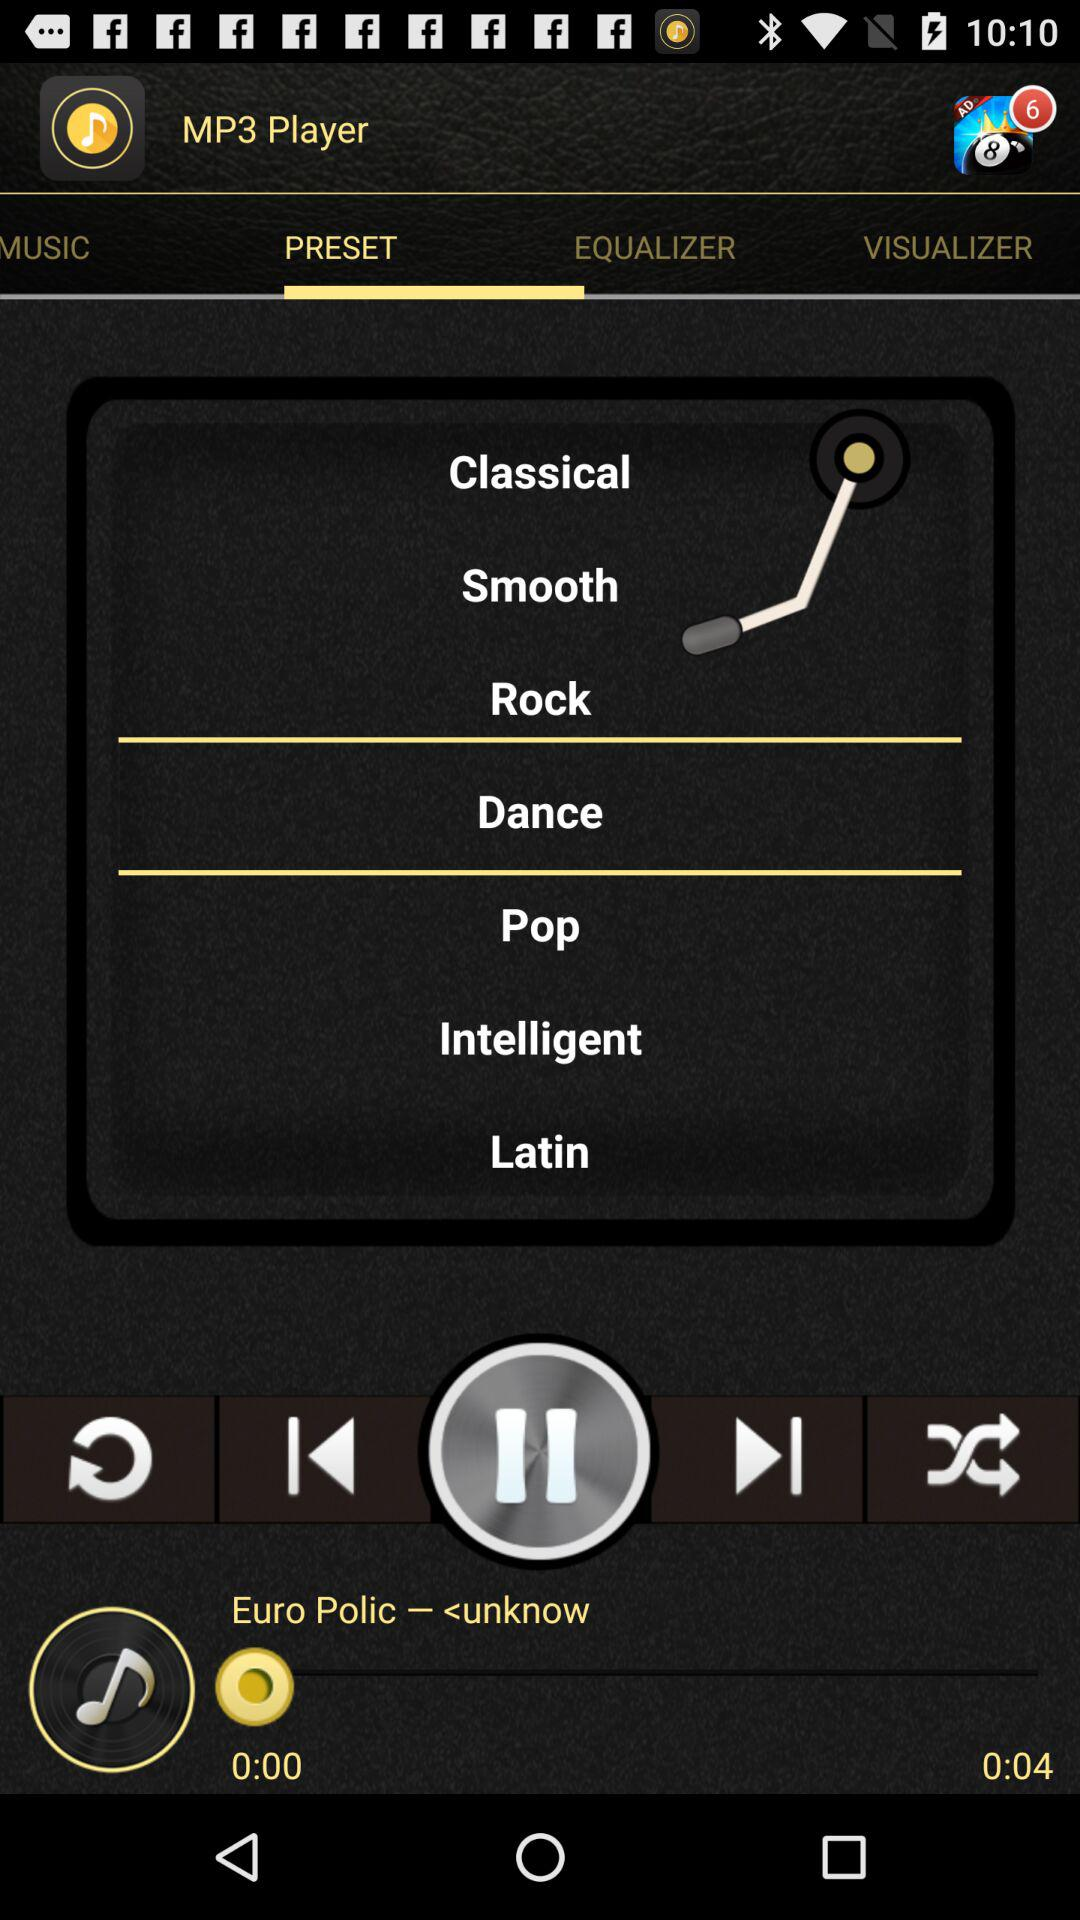What is the name of the song that is playing? The song "Euro Polic – <unknow" is playing. 